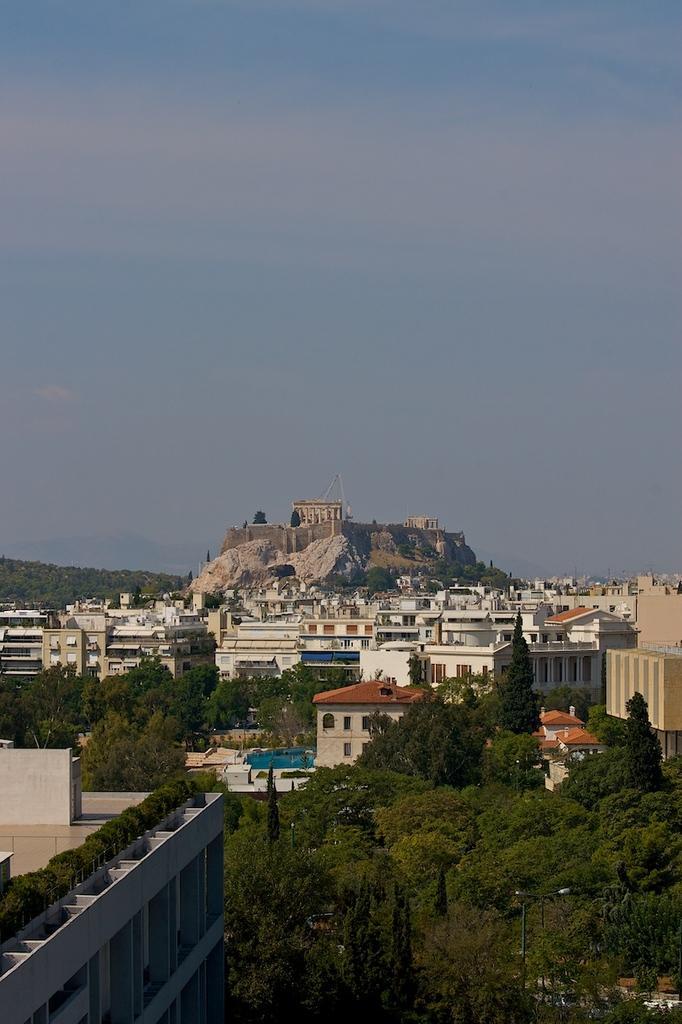Could you give a brief overview of what you see in this image? This is an aerial view image of a place which contains trees, houses, buildings and a mountain. 